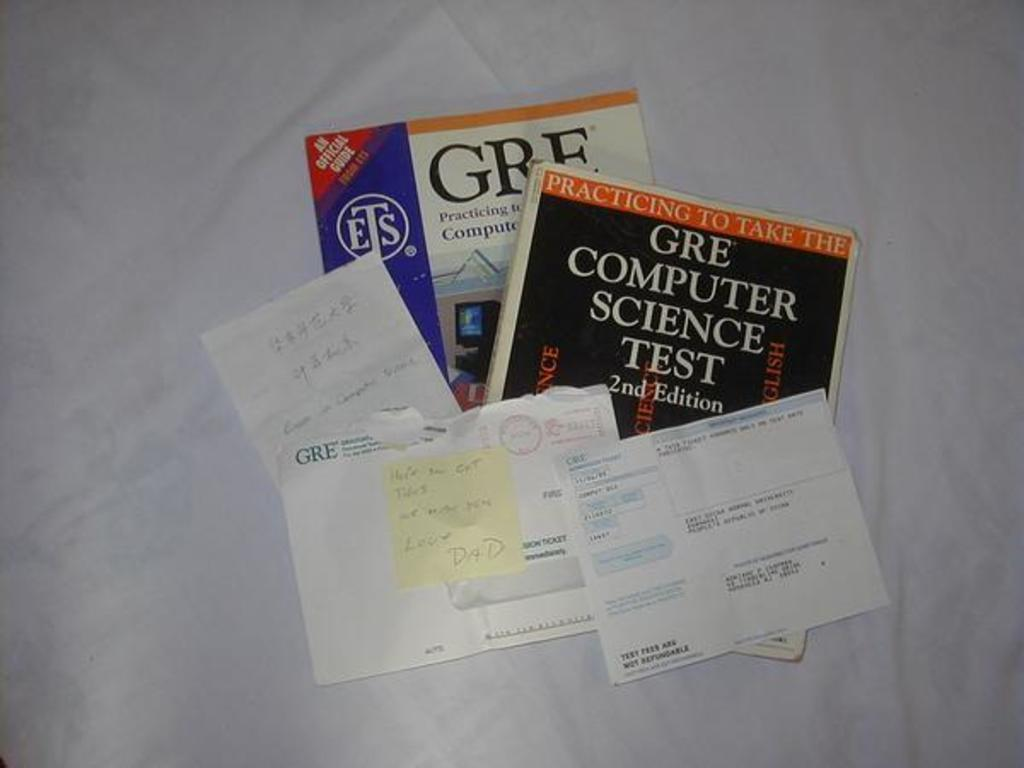<image>
Write a terse but informative summary of the picture. Two GRE test books are displayed with some papers on top of them. 